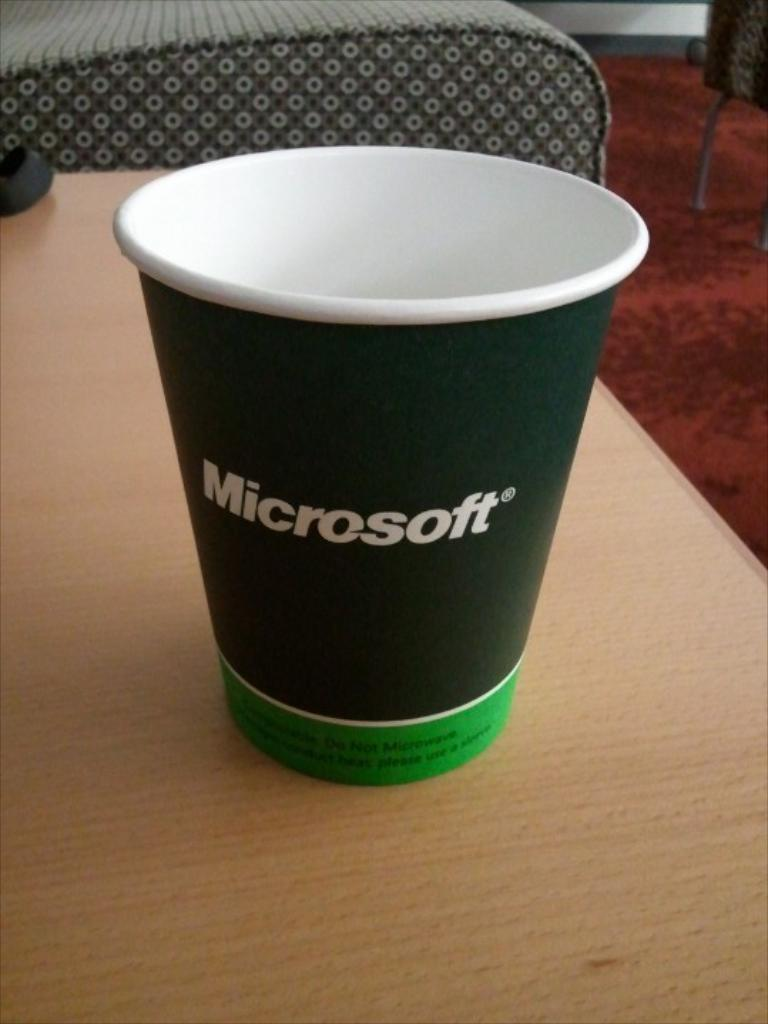What type of furniture can be seen in the background of the image? There are chairs in the background of the image. What object is on the table in the image? There is a glass on a table in the image. How many dinosaurs are present in the image? There are no dinosaurs present in the image. What type of sheep can be seen grazing in the background? There are no sheep present in the image. 